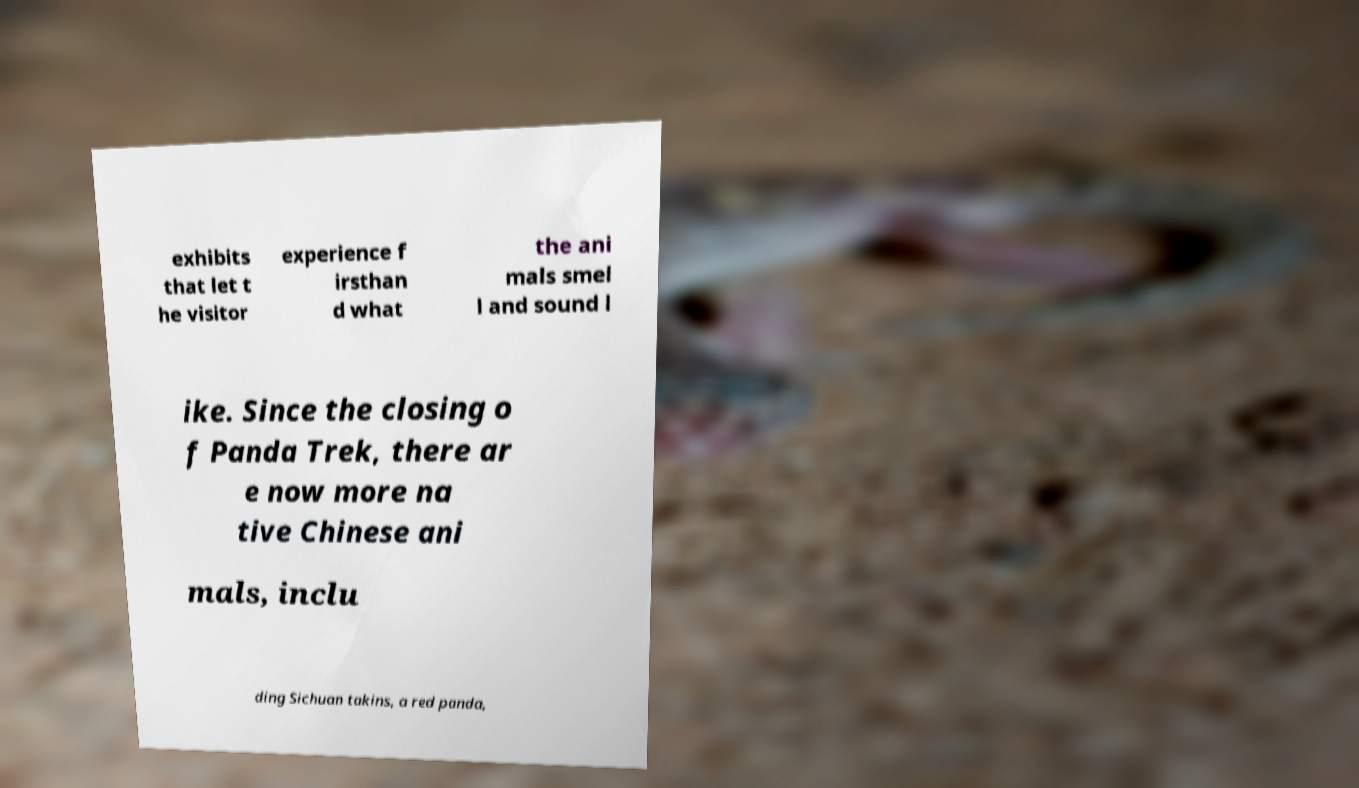Please read and relay the text visible in this image. What does it say? exhibits that let t he visitor experience f irsthan d what the ani mals smel l and sound l ike. Since the closing o f Panda Trek, there ar e now more na tive Chinese ani mals, inclu ding Sichuan takins, a red panda, 